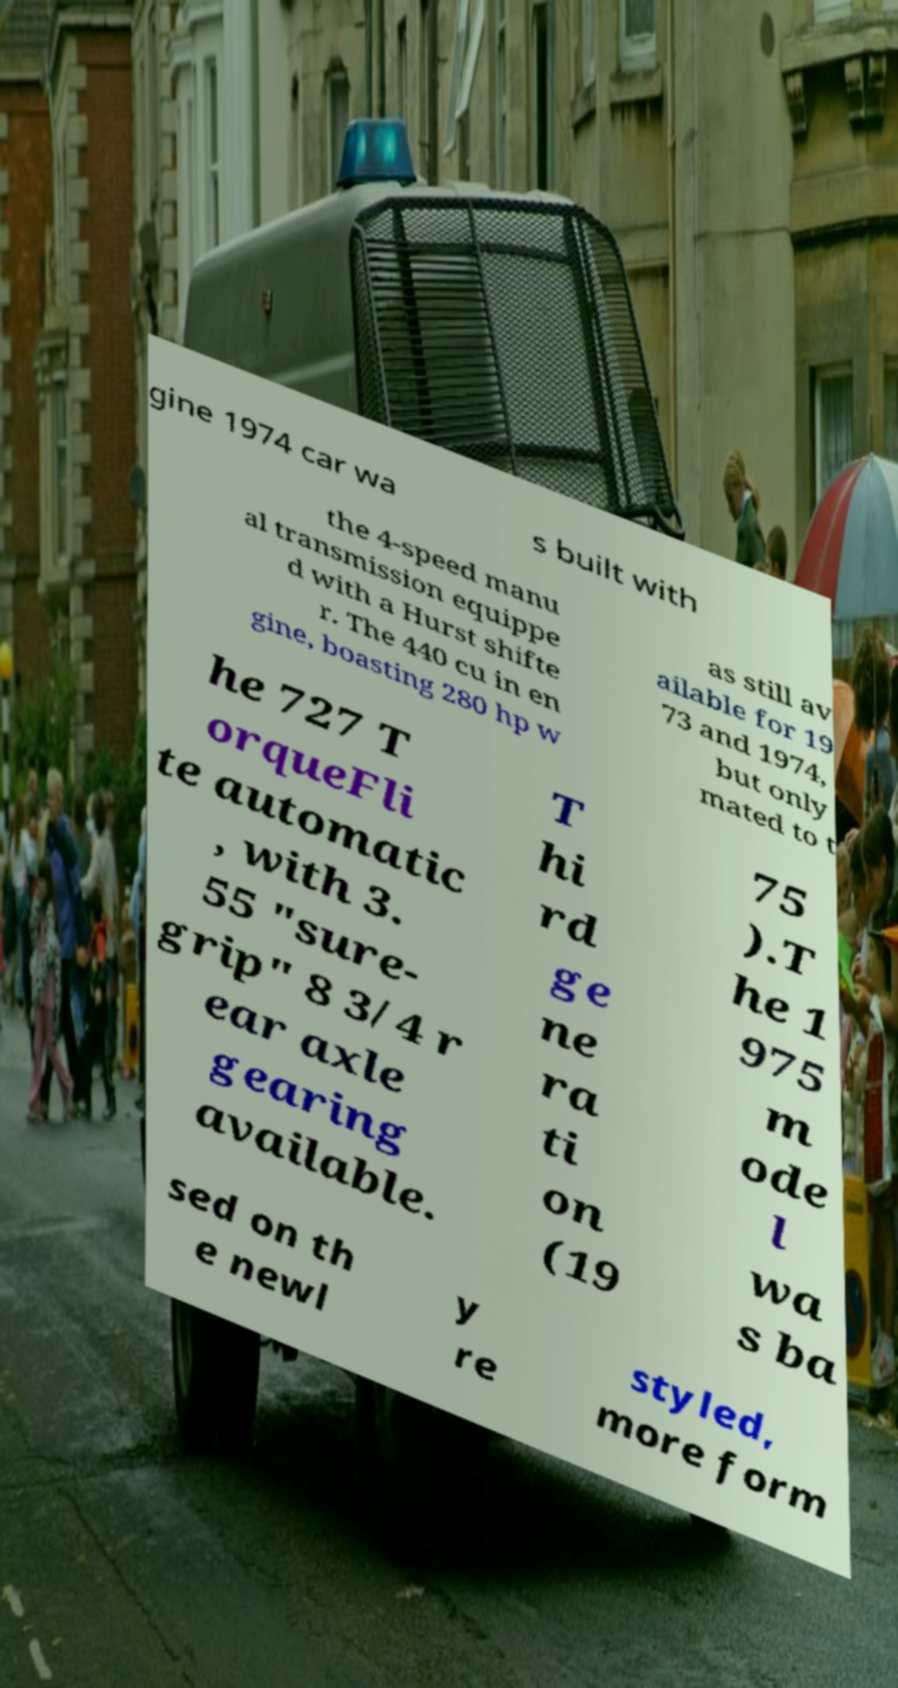Can you read and provide the text displayed in the image?This photo seems to have some interesting text. Can you extract and type it out for me? gine 1974 car wa s built with the 4-speed manu al transmission equippe d with a Hurst shifte r. The 440 cu in en gine, boasting 280 hp w as still av ailable for 19 73 and 1974, but only mated to t he 727 T orqueFli te automatic , with 3. 55 "sure- grip" 8 3/4 r ear axle gearing available. T hi rd ge ne ra ti on (19 75 ).T he 1 975 m ode l wa s ba sed on th e newl y re styled, more form 